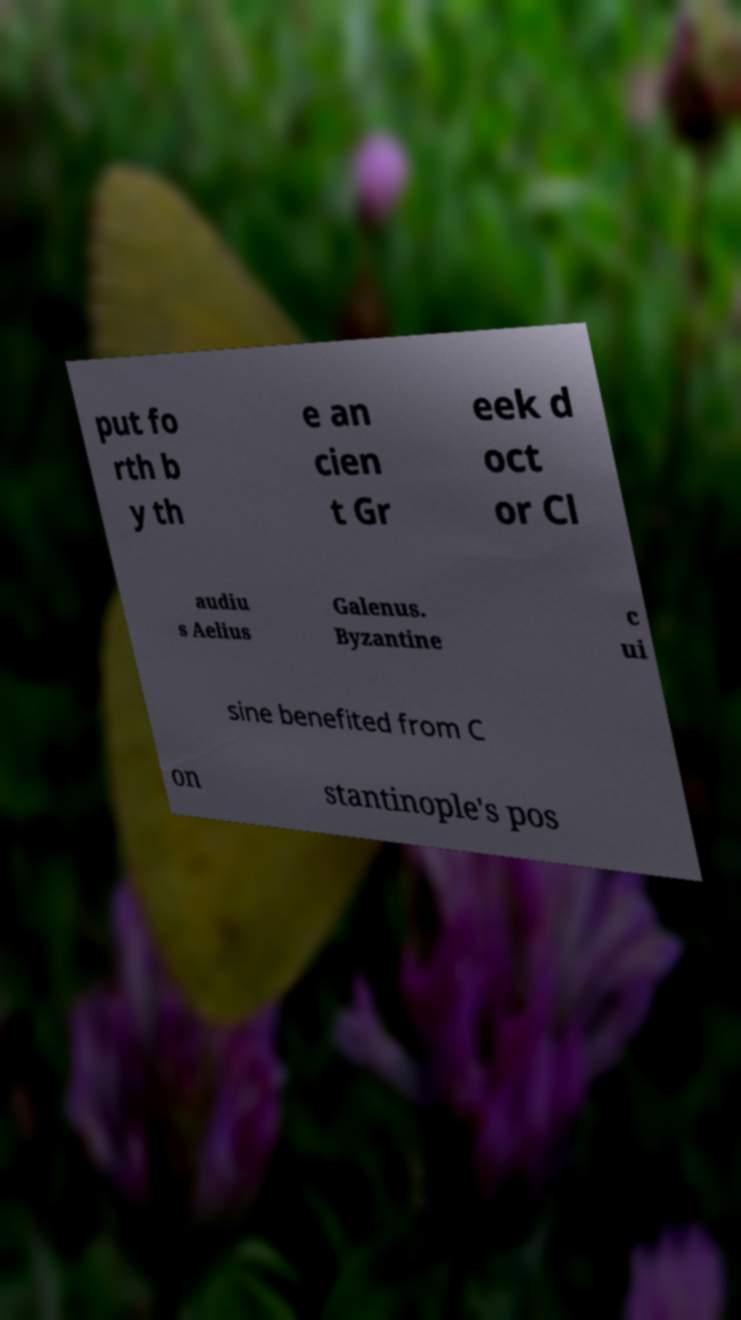Can you accurately transcribe the text from the provided image for me? put fo rth b y th e an cien t Gr eek d oct or Cl audiu s Aelius Galenus. Byzantine c ui sine benefited from C on stantinople's pos 